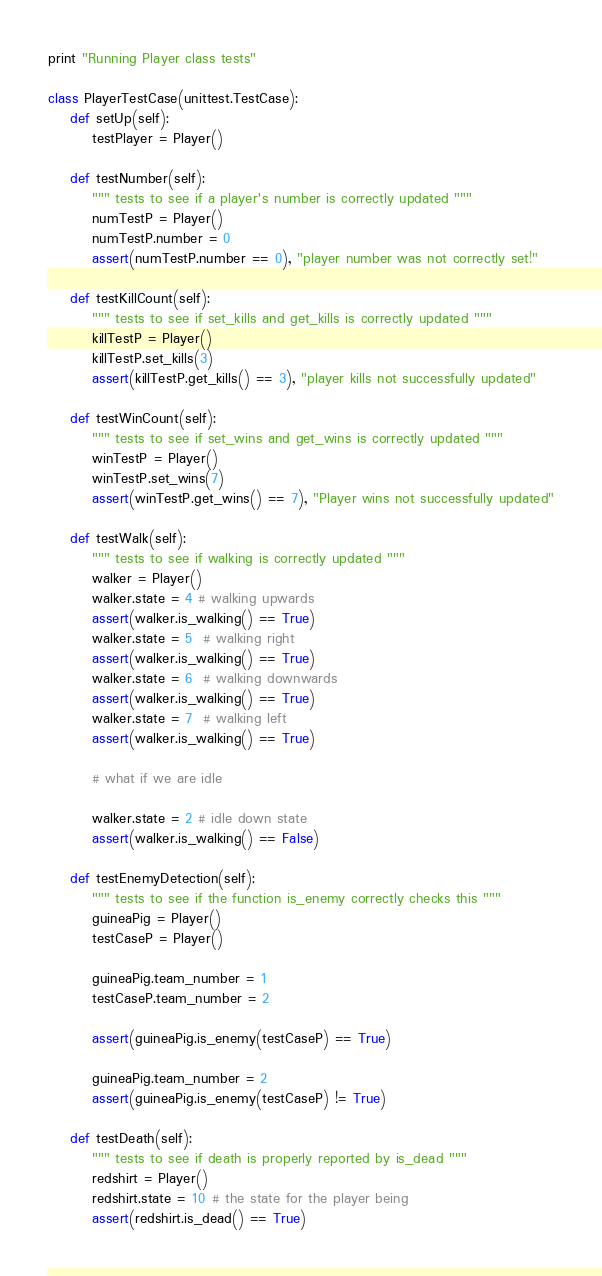Convert code to text. <code><loc_0><loc_0><loc_500><loc_500><_Python_>print "Running Player class tests"

class PlayerTestCase(unittest.TestCase):
    def setUp(self):
        testPlayer = Player()

    def testNumber(self):
        """ tests to see if a player's number is correctly updated """
        numTestP = Player()
        numTestP.number = 0
        assert(numTestP.number == 0), "player number was not correctly set!"

    def testKillCount(self):
        """ tests to see if set_kills and get_kills is correctly updated """
        killTestP = Player()
        killTestP.set_kills(3)
        assert(killTestP.get_kills() == 3), "player kills not successfully updated"

    def testWinCount(self):
        """ tests to see if set_wins and get_wins is correctly updated """
        winTestP = Player()
        winTestP.set_wins(7)
        assert(winTestP.get_wins() == 7), "Player wins not successfully updated"

    def testWalk(self):
        """ tests to see if walking is correctly updated """
        walker = Player()
        walker.state = 4 # walking upwards
        assert(walker.is_walking() == True)
        walker.state = 5  # walking right
        assert(walker.is_walking() == True)
        walker.state = 6  # walking downwards
        assert(walker.is_walking() == True)
        walker.state = 7  # walking left
        assert(walker.is_walking() == True)

        # what if we are idle

        walker.state = 2 # idle down state
        assert(walker.is_walking() == False)

    def testEnemyDetection(self):
        """ tests to see if the function is_enemy correctly checks this """
        guineaPig = Player()
        testCaseP = Player()

        guineaPig.team_number = 1
        testCaseP.team_number = 2

        assert(guineaPig.is_enemy(testCaseP) == True)

        guineaPig.team_number = 2
        assert(guineaPig.is_enemy(testCaseP) != True)

    def testDeath(self):
        """ tests to see if death is properly reported by is_dead """
        redshirt = Player()
        redshirt.state = 10 # the state for the player being
        assert(redshirt.is_dead() == True)
</code> 